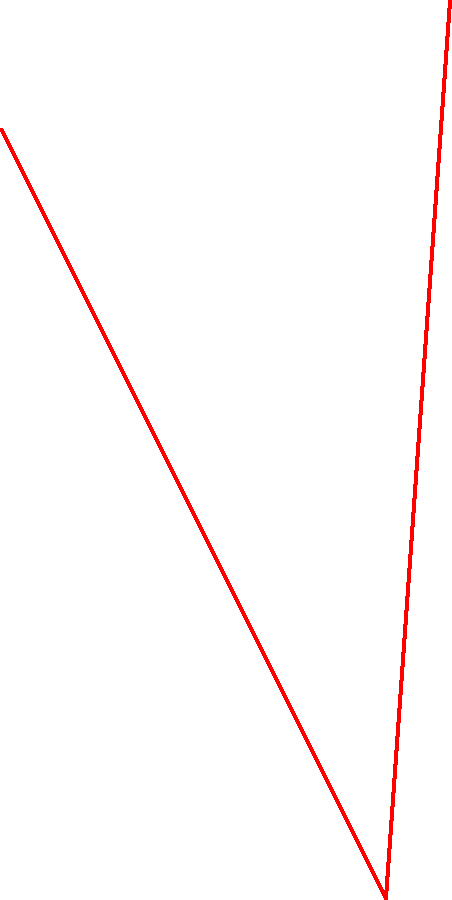Based on the soil moisture sensor readings shown in the graph, at what percentage of soil moisture should irrigation be applied to maintain optimal conditions for rice growth? To determine the optimal soil moisture percentage for irrigation, we need to analyze the graph:

1. The graph shows soil moisture decreasing over time from 20% to 8%.
2. At day 7, there's a sharp increase in soil moisture to 22%, indicating irrigation.
3. For rice cultivation, it's generally recommended to maintain soil moisture between 80-100% of field capacity.
4. In this case, we see that irrigation is applied when soil moisture drops to about 8%.
5. To maintain optimal conditions and avoid water stress, it's better to irrigate before the soil gets too dry.
6. A good rule of thumb is to irrigate when soil moisture reaches about 50% of its maximum observed value.
7. The maximum observed soil moisture is 22% (after irrigation).
8. 50% of 22% is 11%.

Therefore, to maintain optimal conditions for rice growth, irrigation should be applied when soil moisture reaches approximately 11%.
Answer: 11% 